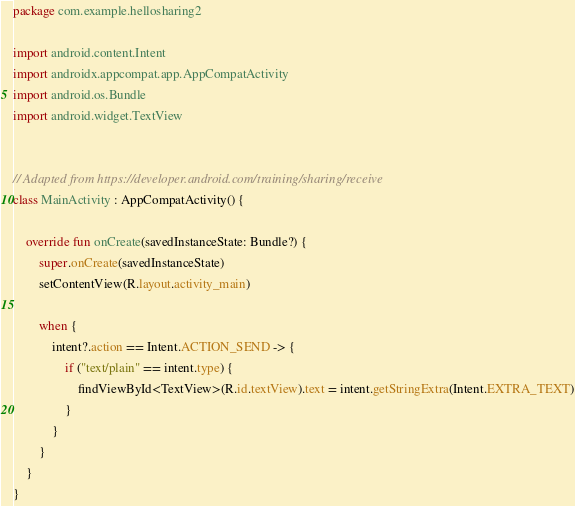<code> <loc_0><loc_0><loc_500><loc_500><_Kotlin_>package com.example.hellosharing2

import android.content.Intent
import androidx.appcompat.app.AppCompatActivity
import android.os.Bundle
import android.widget.TextView


// Adapted from https://developer.android.com/training/sharing/receive
class MainActivity : AppCompatActivity() {

    override fun onCreate(savedInstanceState: Bundle?) {
        super.onCreate(savedInstanceState)
        setContentView(R.layout.activity_main)

        when {
            intent?.action == Intent.ACTION_SEND -> {
                if ("text/plain" == intent.type) {
                    findViewById<TextView>(R.id.textView).text = intent.getStringExtra(Intent.EXTRA_TEXT)
                }
            }
        }
    }
}
</code> 